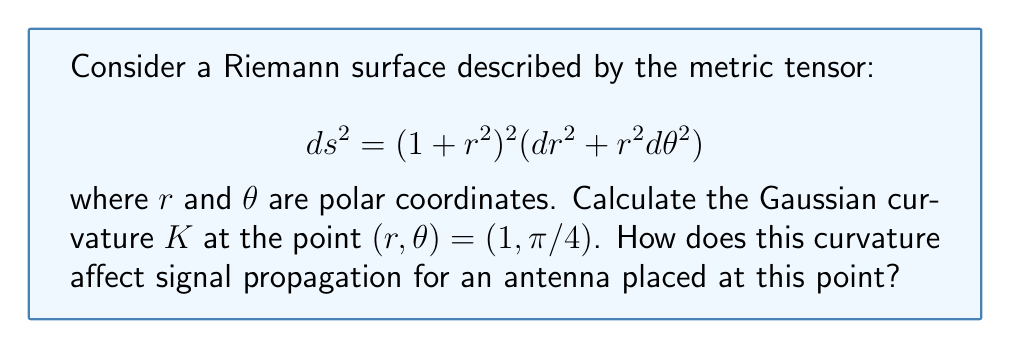Teach me how to tackle this problem. To solve this problem, we'll follow these steps:

1) The Gaussian curvature $K$ for a surface with metric $ds^2 = E(dr^2 + r^2d\theta^2)$ is given by:

   $$K = -\frac{1}{2E^2}\left(\frac{\partial^2 E}{\partial r^2} + \frac{1}{r}\frac{\partial E}{\partial r}\right)$$

2) In our case, $E = (1 + r^2)^2$. Let's calculate the necessary derivatives:

   $$\frac{\partial E}{\partial r} = 2(1 + r^2)(2r) = 4r(1 + r^2)$$
   
   $$\frac{\partial^2 E}{\partial r^2} = 4(1 + r^2) + 8r^2 = 4(1 + 3r^2)$$

3) Substituting these into the curvature formula:

   $$K = -\frac{1}{2(1 + r^2)^4}\left(4(1 + 3r^2) + \frac{1}{r}4r(1 + r^2)\right)$$

4) Simplifying:

   $$K = -\frac{1}{2(1 + r^2)^4}\left(4(1 + 3r^2) + 4(1 + r^2)\right) = -\frac{4(2 + 3r^2)}{(1 + r^2)^4}$$

5) At the point $(r, \theta) = (1, \pi/4)$, we have:

   $$K = -\frac{4(2 + 3(1)^2)}{(1 + (1)^2)^4} = -\frac{20}{16^2} = -\frac{5}{64}$$

6) The negative curvature at this point indicates that the surface is hyperbolic-like in this region. For antenna design, this has several implications:

   a) Signal propagation in negatively curved spaces tends to diverge, which can lead to wider coverage but potentially weaker signal strength at long distances.
   
   b) The curvature can cause multipath effects, where signals take multiple paths to reach the receiver, potentially causing interference or fading.
   
   c) The antenna design may need to be adjusted to compensate for this curvature, possibly by using directional antennas or array configurations to focus the signal in desired directions.
Answer: $K = -\frac{5}{64}$; Negative curvature causes signal divergence and potential multipath effects. 